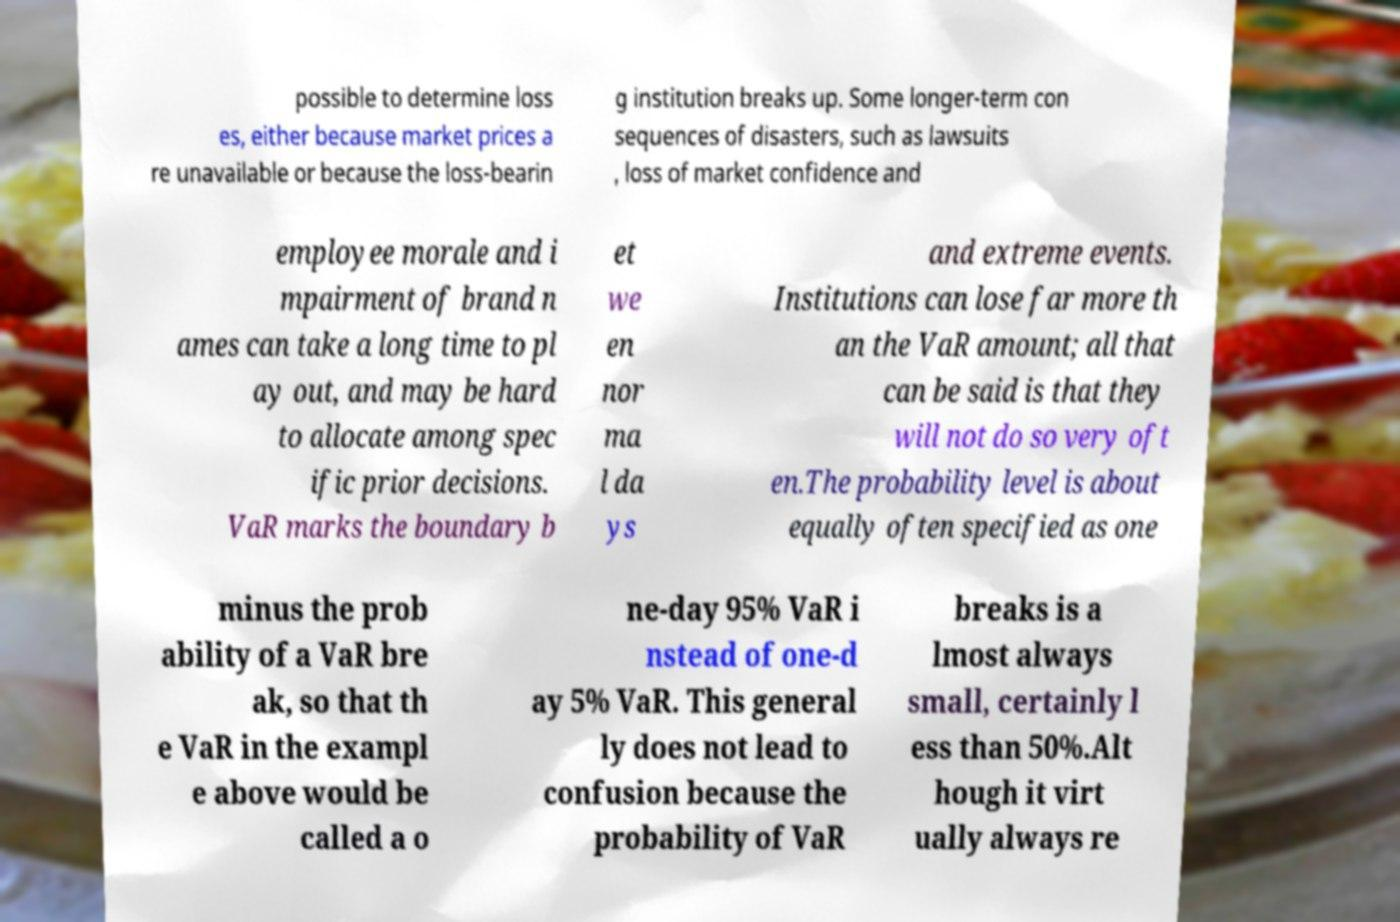Please identify and transcribe the text found in this image. possible to determine loss es, either because market prices a re unavailable or because the loss-bearin g institution breaks up. Some longer-term con sequences of disasters, such as lawsuits , loss of market confidence and employee morale and i mpairment of brand n ames can take a long time to pl ay out, and may be hard to allocate among spec ific prior decisions. VaR marks the boundary b et we en nor ma l da ys and extreme events. Institutions can lose far more th an the VaR amount; all that can be said is that they will not do so very oft en.The probability level is about equally often specified as one minus the prob ability of a VaR bre ak, so that th e VaR in the exampl e above would be called a o ne-day 95% VaR i nstead of one-d ay 5% VaR. This general ly does not lead to confusion because the probability of VaR breaks is a lmost always small, certainly l ess than 50%.Alt hough it virt ually always re 